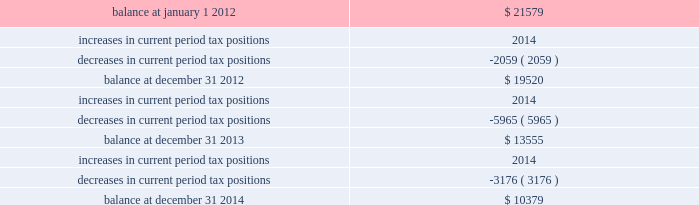Majority of the increased tax position is attributable to temporary differences .
The increase in 2014 current period tax positions related primarily to the company 2019s change in tax accounting method filed in 2008 for repair and maintenance costs on its utility plant .
The company does not anticipate material changes to its unrecognized tax benefits within the next year .
If the company sustains all of its positions at december 31 , 2014 and 2013 , an unrecognized tax benefit of $ 9444 and $ 7439 , respectively , excluding interest and penalties , would impact the company 2019s effective tax rate .
The table summarizes the changes in the company 2019s valuation allowance: .
Included in 2013 is a discrete tax benefit totaling $ 2979 associated with an entity re-organization within the company 2019s market-based operations segment that allowed for the utilization of state net operating loss carryforwards and the release of an associated valuation allowance .
Note 13 : employee benefits pension and other postretirement benefits the company maintains noncontributory defined benefit pension plans covering eligible employees of its regulated utility and shared services operations .
Benefits under the plans are based on the employee 2019s years of service and compensation .
The pension plans have been closed for all employees .
The pension plans were closed for most employees hired on or after january 1 , 2006 .
Union employees hired on or after january 1 , 2001 had their accrued benefit frozen and will be able to receive this benefit as a lump sum upon termination or retirement .
Union employees hired on or after january 1 , 2001 and non-union employees hired on or after january 1 , 2006 are provided with a 5.25% ( 5.25 % ) of base pay defined contribution plan .
The company does not participate in a multiemployer plan .
The company 2019s pension funding practice is to contribute at least the greater of the minimum amount required by the employee retirement income security act of 1974 or the normal cost .
Further , the company will consider additional contributions if needed to avoid 201cat risk 201d status and benefit restrictions under the pension protection act of 2006 .
The company may also consider increased contributions , based on other financial requirements and the plans 2019 funded position .
Pension plan assets are invested in a number of actively managed and commingled funds including equity and bond funds , fixed income securities , guaranteed interest contracts with insurance companies , real estate funds and real estate investment trusts ( 201creits 201d ) .
Pension expense in excess of the amount contributed to the pension plans is deferred by certain regulated subsidiaries pending future recovery in rates charged for utility services as contributions are made to the plans .
( see note 6 ) the company also has unfunded noncontributory supplemental non-qualified pension plans that provide additional retirement benefits to certain employees. .
Between 2012 and december 312014 what was the cumulative decrease in tax positions? 
Rationale: the cumulative decrease in tax position from 2012 to 2013 is the sum of the change from year to year
Computations: ((2059 + 5965) + 3176)
Answer: 11200.0. 